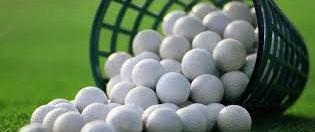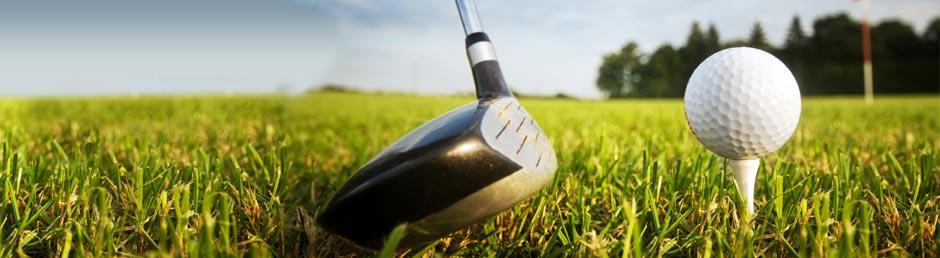The first image is the image on the left, the second image is the image on the right. Given the left and right images, does the statement "A golf ball is on a tee in one image." hold true? Answer yes or no. Yes. The first image is the image on the left, the second image is the image on the right. Considering the images on both sides, is "At least one of the balls is sitting near the hole." valid? Answer yes or no. No. 